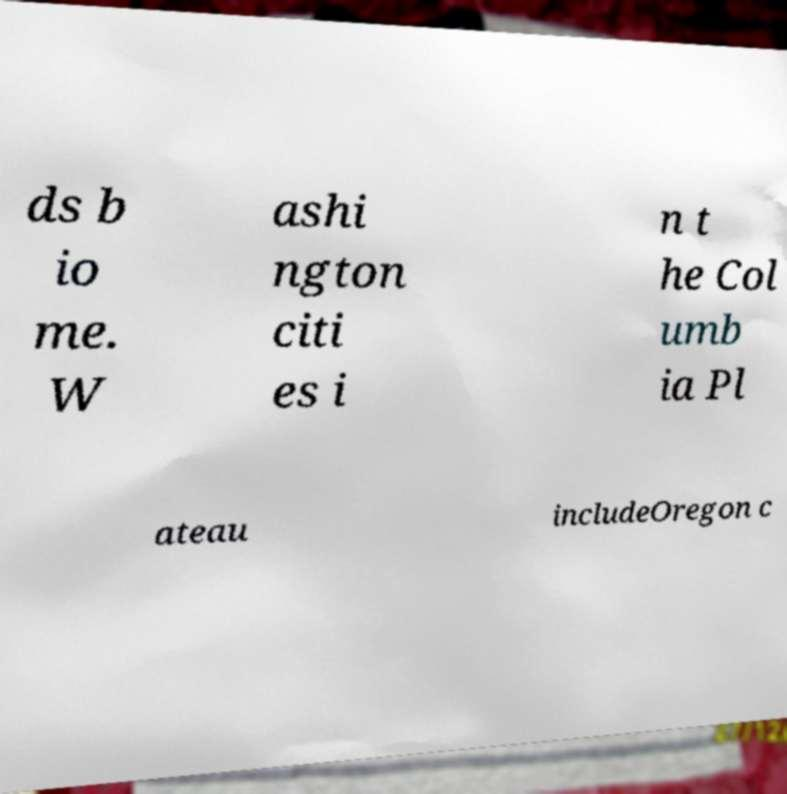For documentation purposes, I need the text within this image transcribed. Could you provide that? ds b io me. W ashi ngton citi es i n t he Col umb ia Pl ateau includeOregon c 